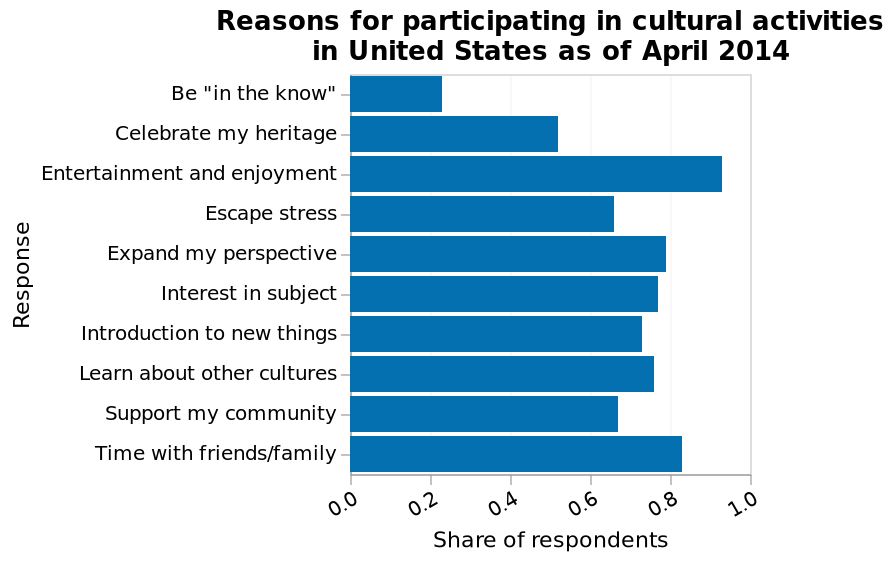<image>
When was this data collected? This data was collected in April 2014. 